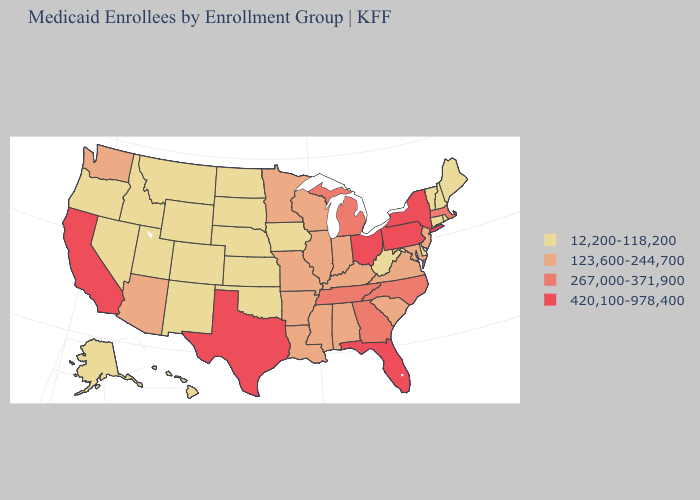Which states have the lowest value in the MidWest?
Write a very short answer. Iowa, Kansas, Nebraska, North Dakota, South Dakota. Among the states that border Michigan , does Indiana have the lowest value?
Short answer required. Yes. Does Tennessee have the highest value in the USA?
Be succinct. No. Among the states that border Rhode Island , does Massachusetts have the highest value?
Write a very short answer. Yes. What is the value of Nevada?
Short answer required. 12,200-118,200. What is the value of South Carolina?
Be succinct. 123,600-244,700. Does Nevada have the highest value in the West?
Concise answer only. No. Does the first symbol in the legend represent the smallest category?
Give a very brief answer. Yes. Which states have the lowest value in the Northeast?
Quick response, please. Connecticut, Maine, New Hampshire, Rhode Island, Vermont. What is the value of Nebraska?
Keep it brief. 12,200-118,200. Does the first symbol in the legend represent the smallest category?
Give a very brief answer. Yes. What is the highest value in the Northeast ?
Keep it brief. 420,100-978,400. Among the states that border Arkansas , which have the lowest value?
Write a very short answer. Oklahoma. Which states have the lowest value in the USA?
Be succinct. Alaska, Colorado, Connecticut, Delaware, Hawaii, Idaho, Iowa, Kansas, Maine, Montana, Nebraska, Nevada, New Hampshire, New Mexico, North Dakota, Oklahoma, Oregon, Rhode Island, South Dakota, Utah, Vermont, West Virginia, Wyoming. Which states have the highest value in the USA?
Quick response, please. California, Florida, New York, Ohio, Pennsylvania, Texas. 